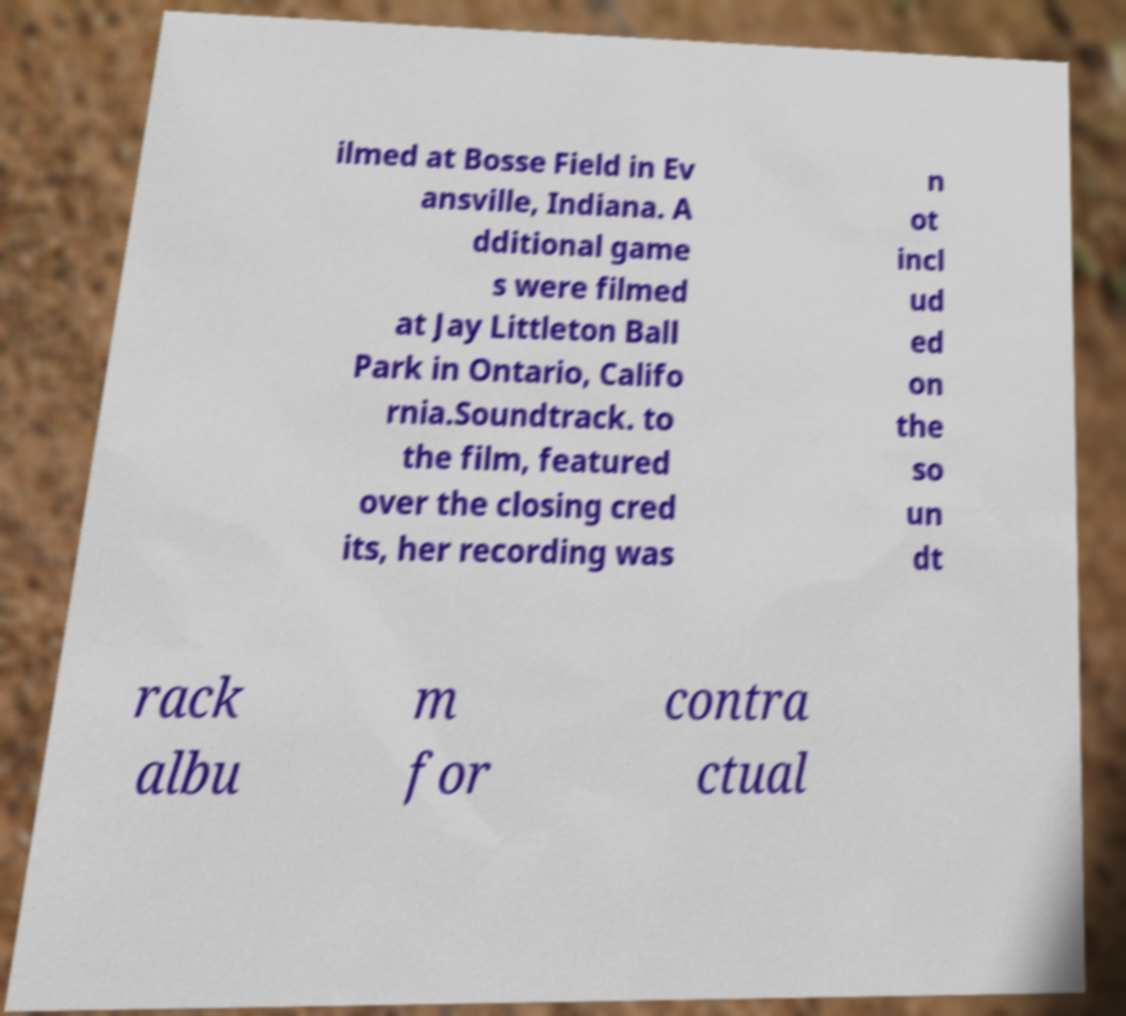Can you read and provide the text displayed in the image?This photo seems to have some interesting text. Can you extract and type it out for me? ilmed at Bosse Field in Ev ansville, Indiana. A dditional game s were filmed at Jay Littleton Ball Park in Ontario, Califo rnia.Soundtrack. to the film, featured over the closing cred its, her recording was n ot incl ud ed on the so un dt rack albu m for contra ctual 